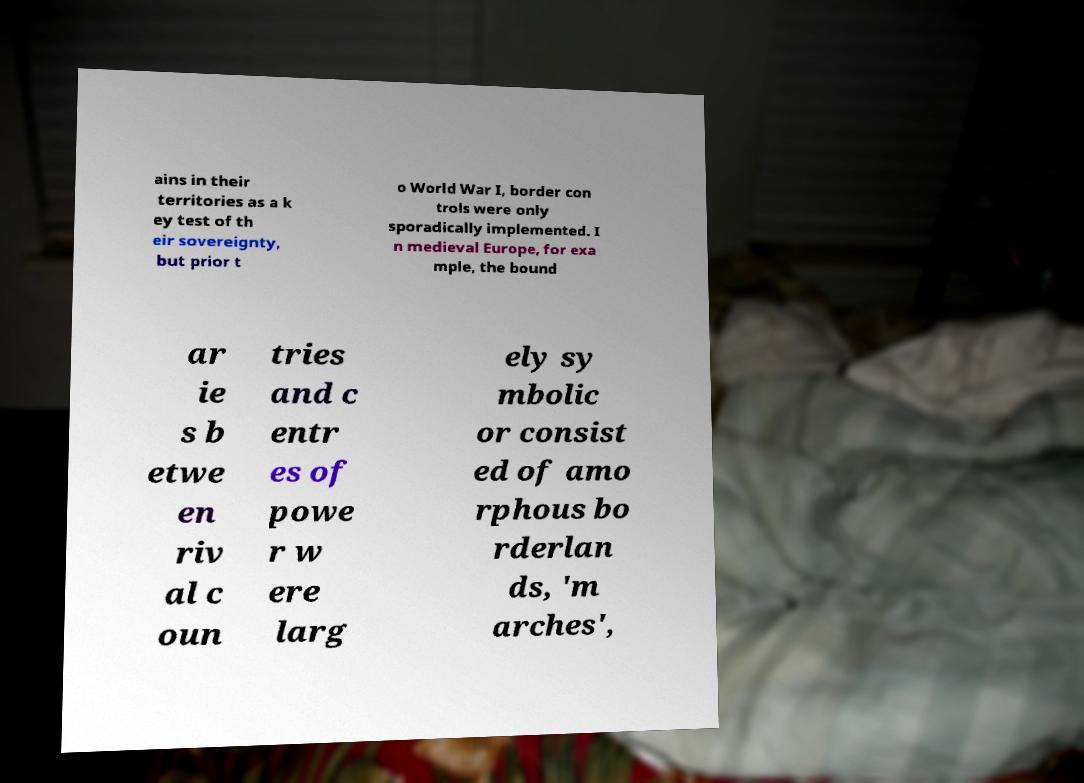There's text embedded in this image that I need extracted. Can you transcribe it verbatim? ains in their territories as a k ey test of th eir sovereignty, but prior t o World War I, border con trols were only sporadically implemented. I n medieval Europe, for exa mple, the bound ar ie s b etwe en riv al c oun tries and c entr es of powe r w ere larg ely sy mbolic or consist ed of amo rphous bo rderlan ds, 'm arches', 